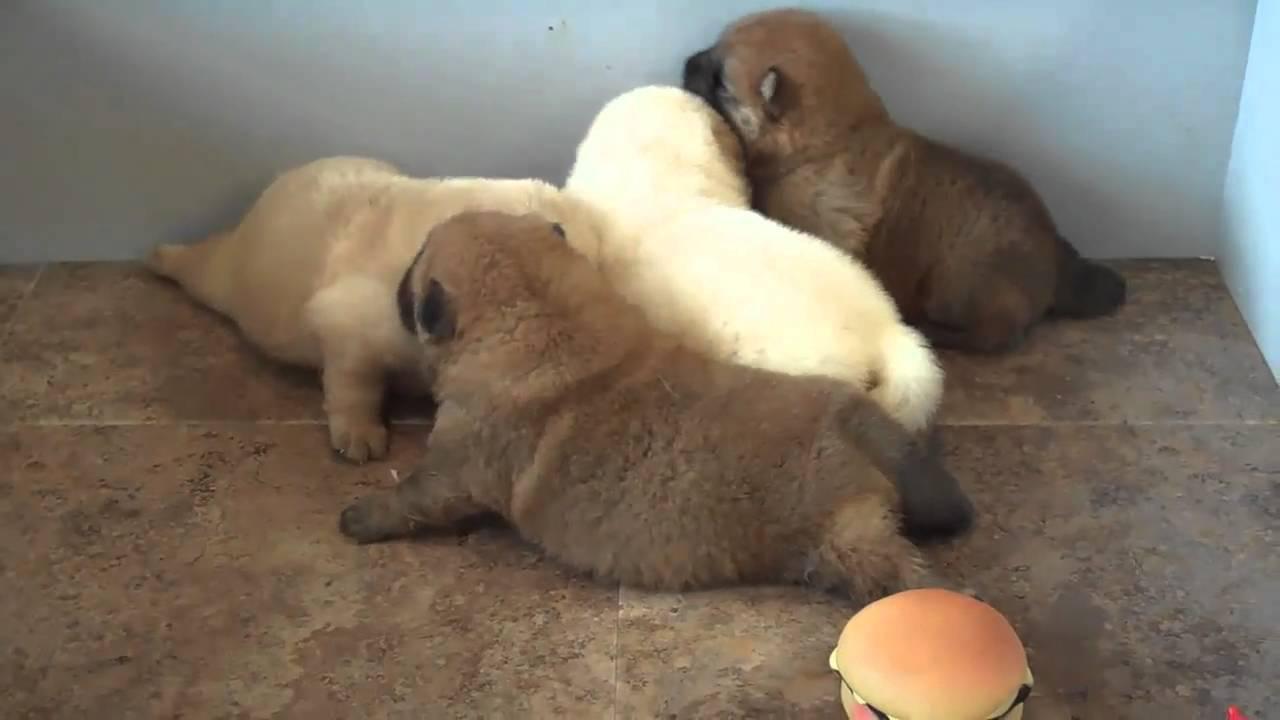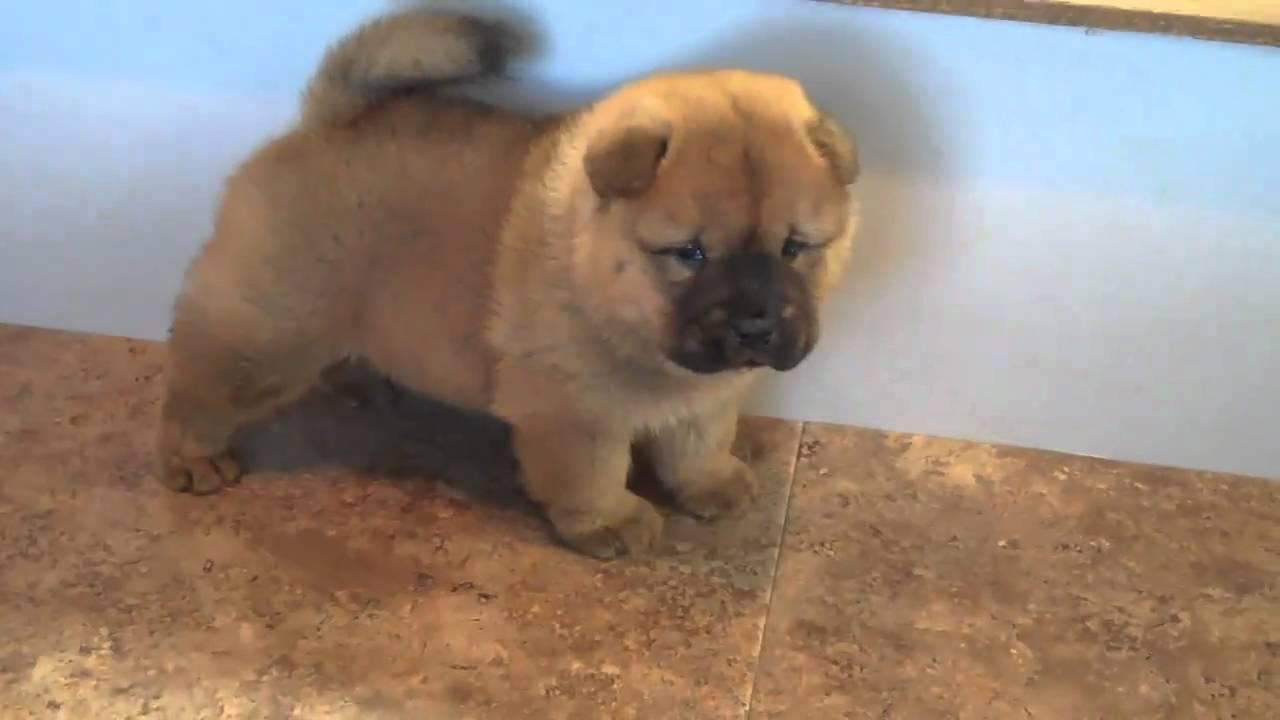The first image is the image on the left, the second image is the image on the right. Considering the images on both sides, is "All dogs shown are chow puppies, one puppy is standing with its body in profile, one puppy has its front paws extended, and at least one of the puppies has a black muzzle." valid? Answer yes or no. No. The first image is the image on the left, the second image is the image on the right. Evaluate the accuracy of this statement regarding the images: "The dog in the image on the right is positioned on a wooden surface.". Is it true? Answer yes or no. No. 